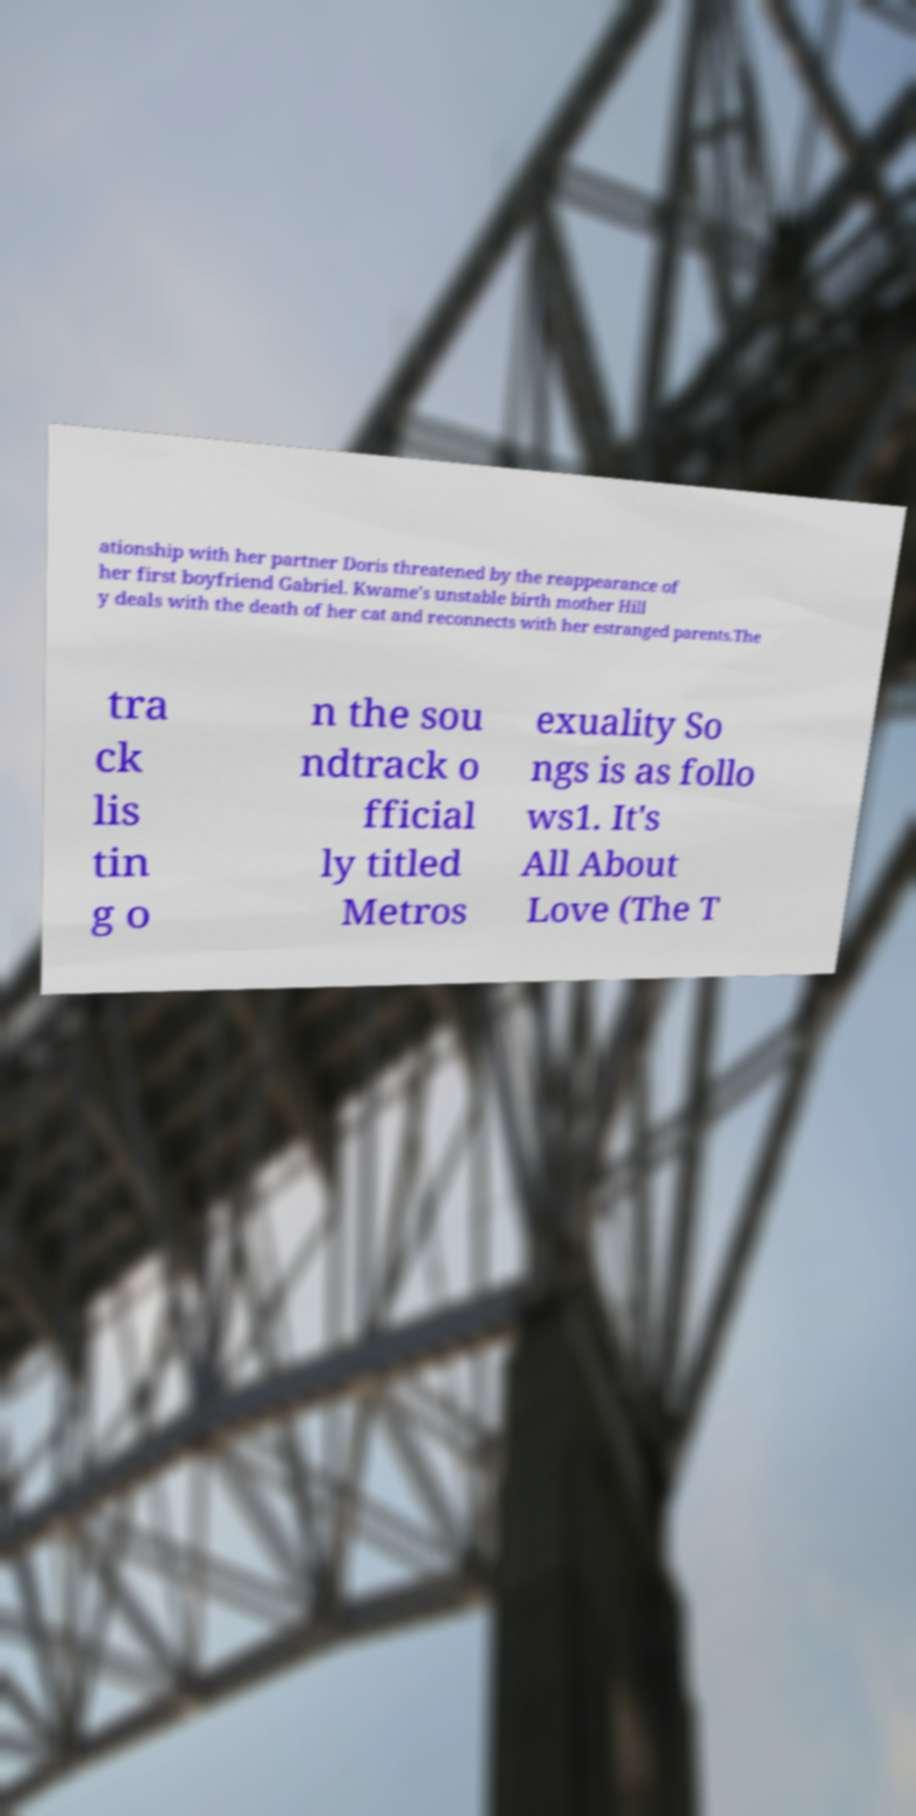There's text embedded in this image that I need extracted. Can you transcribe it verbatim? ationship with her partner Doris threatened by the reappearance of her first boyfriend Gabriel. Kwame's unstable birth mother Hill y deals with the death of her cat and reconnects with her estranged parents.The tra ck lis tin g o n the sou ndtrack o fficial ly titled Metros exuality So ngs is as follo ws1. It's All About Love (The T 